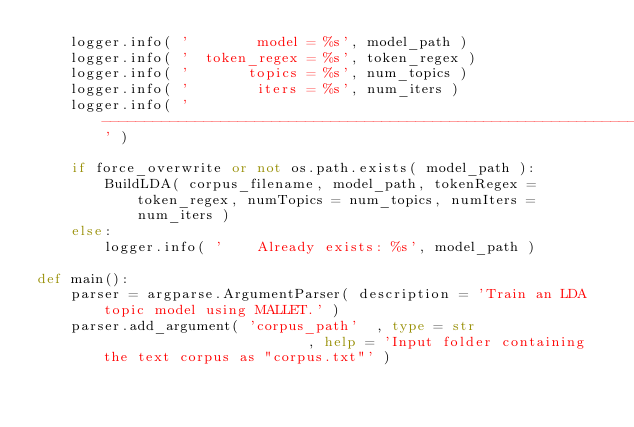Convert code to text. <code><loc_0><loc_0><loc_500><loc_500><_Python_>	logger.info( '        model = %s', model_path )
	logger.info( '  token_regex = %s', token_regex )
	logger.info( '       topics = %s', num_topics )
	logger.info( '        iters = %s', num_iters )
	logger.info( '--------------------------------------------------------------------------------' )
	
	if force_overwrite or not os.path.exists( model_path ):
		BuildLDA( corpus_filename, model_path, tokenRegex = token_regex, numTopics = num_topics, numIters = num_iters )
	else:
		logger.info( '    Already exists: %s', model_path )

def main():
	parser = argparse.ArgumentParser( description = 'Train an LDA topic model using MALLET.' )
	parser.add_argument( 'corpus_path'  , type = str                         , help = 'Input folder containing the text corpus as "corpus.txt"' )</code> 